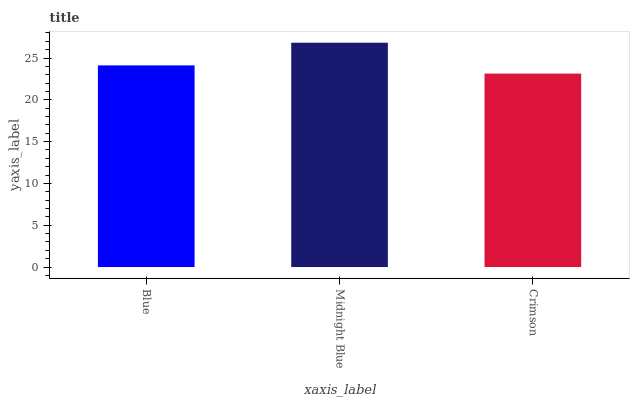Is Crimson the minimum?
Answer yes or no. Yes. Is Midnight Blue the maximum?
Answer yes or no. Yes. Is Midnight Blue the minimum?
Answer yes or no. No. Is Crimson the maximum?
Answer yes or no. No. Is Midnight Blue greater than Crimson?
Answer yes or no. Yes. Is Crimson less than Midnight Blue?
Answer yes or no. Yes. Is Crimson greater than Midnight Blue?
Answer yes or no. No. Is Midnight Blue less than Crimson?
Answer yes or no. No. Is Blue the high median?
Answer yes or no. Yes. Is Blue the low median?
Answer yes or no. Yes. Is Midnight Blue the high median?
Answer yes or no. No. Is Crimson the low median?
Answer yes or no. No. 